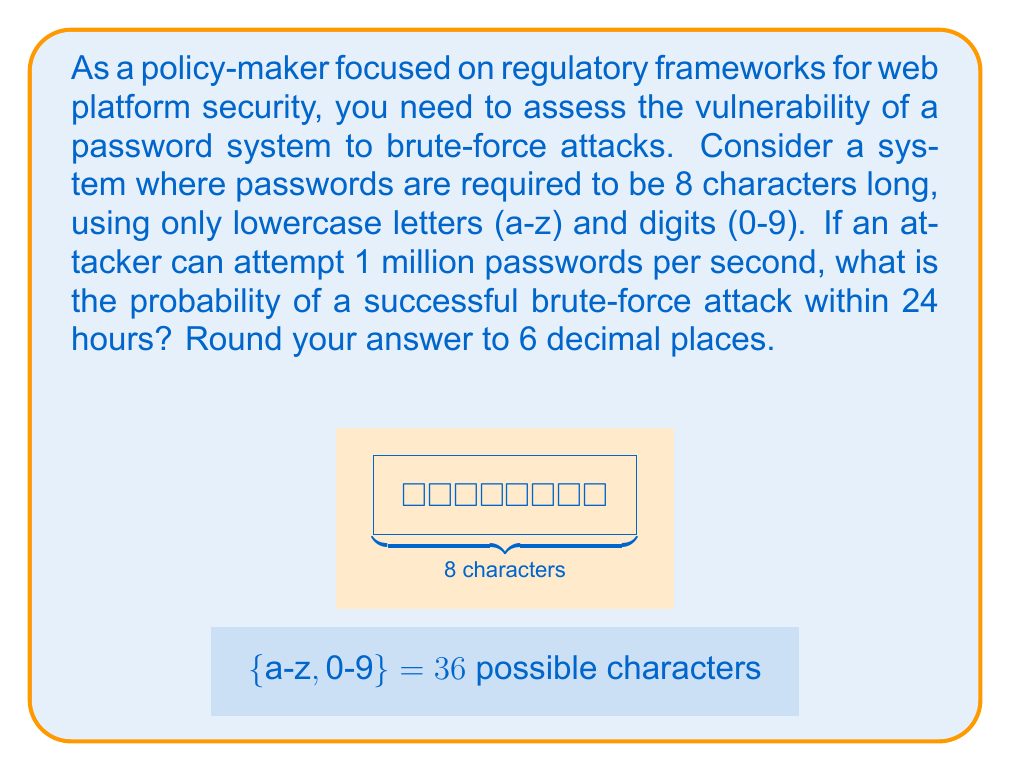Can you answer this question? Let's approach this step-by-step:

1) First, calculate the total number of possible passwords:
   - 26 lowercase letters + 10 digits = 36 possible characters
   - Password length is 8
   - Total combinations: $36^8 = 2,821,109,907,456$

2) Calculate how many attempts the attacker can make in 24 hours:
   - 1 million attempts per second
   - 24 hours = 24 * 60 * 60 = 86,400 seconds
   - Total attempts: $86,400 * 1,000,000 = 86,400,000,000$

3) The probability of success is the number of attempts divided by the total number of possible passwords:

   $$P(\text{success}) = \frac{\text{Number of attempts}}{\text{Total possible passwords}}$$

   $$P(\text{success}) = \frac{86,400,000,000}{2,821,109,907,456}$$

4) Simplify and calculate:
   $$P(\text{success}) = 0.030626$$

5) Rounding to 6 decimal places:
   $$P(\text{success}) \approx 0.030626$$

This means there's about a 3.0626% chance of a successful brute-force attack within 24 hours.
Answer: 0.030626 